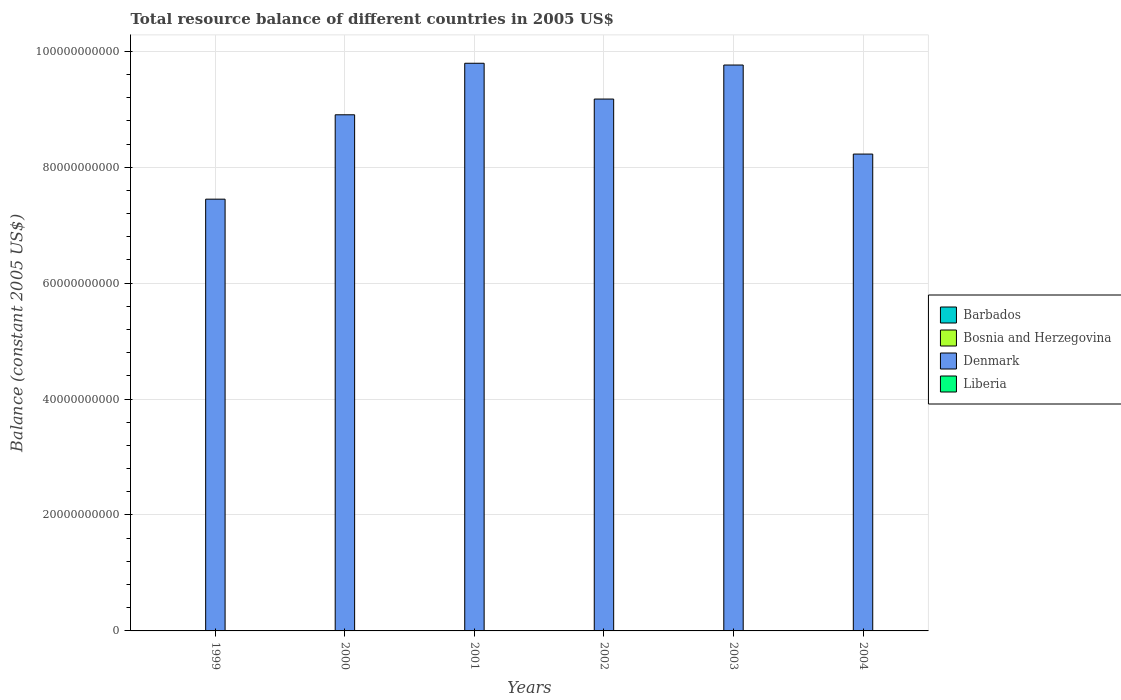How many different coloured bars are there?
Offer a terse response. 2. Are the number of bars per tick equal to the number of legend labels?
Give a very brief answer. No. How many bars are there on the 3rd tick from the right?
Give a very brief answer. 2. What is the total resource balance in Bosnia and Herzegovina in 2003?
Your answer should be very brief. 0. Across all years, what is the maximum total resource balance in Denmark?
Offer a very short reply. 9.79e+1. Across all years, what is the minimum total resource balance in Barbados?
Your answer should be very brief. 0. In which year was the total resource balance in Liberia maximum?
Give a very brief answer. 2002. What is the total total resource balance in Liberia in the graph?
Give a very brief answer. 7.70e+07. What is the difference between the total resource balance in Denmark in 2002 and that in 2004?
Provide a short and direct response. 9.49e+09. What is the difference between the total resource balance in Denmark in 2000 and the total resource balance in Barbados in 2003?
Keep it short and to the point. 8.90e+1. What is the average total resource balance in Denmark per year?
Your answer should be very brief. 8.89e+1. In how many years, is the total resource balance in Bosnia and Herzegovina greater than 76000000000 US$?
Offer a terse response. 0. What is the ratio of the total resource balance in Denmark in 2003 to that in 2004?
Keep it short and to the point. 1.19. Is the total resource balance in Denmark in 1999 less than that in 2003?
Your answer should be compact. Yes. What is the difference between the highest and the second highest total resource balance in Liberia?
Give a very brief answer. 4.96e+07. What is the difference between the highest and the lowest total resource balance in Liberia?
Provide a short and direct response. 6.29e+07. Is it the case that in every year, the sum of the total resource balance in Barbados and total resource balance in Liberia is greater than the total resource balance in Bosnia and Herzegovina?
Keep it short and to the point. No. Are all the bars in the graph horizontal?
Keep it short and to the point. No. What is the difference between two consecutive major ticks on the Y-axis?
Offer a very short reply. 2.00e+1. Are the values on the major ticks of Y-axis written in scientific E-notation?
Offer a terse response. No. Does the graph contain any zero values?
Ensure brevity in your answer.  Yes. Does the graph contain grids?
Your answer should be very brief. Yes. Where does the legend appear in the graph?
Give a very brief answer. Center right. How many legend labels are there?
Make the answer very short. 4. How are the legend labels stacked?
Offer a terse response. Vertical. What is the title of the graph?
Offer a terse response. Total resource balance of different countries in 2005 US$. What is the label or title of the X-axis?
Offer a very short reply. Years. What is the label or title of the Y-axis?
Provide a short and direct response. Balance (constant 2005 US$). What is the Balance (constant 2005 US$) in Denmark in 1999?
Your answer should be very brief. 7.45e+1. What is the Balance (constant 2005 US$) in Barbados in 2000?
Ensure brevity in your answer.  0. What is the Balance (constant 2005 US$) of Bosnia and Herzegovina in 2000?
Your answer should be compact. 0. What is the Balance (constant 2005 US$) of Denmark in 2000?
Offer a terse response. 8.90e+1. What is the Balance (constant 2005 US$) in Denmark in 2001?
Give a very brief answer. 9.79e+1. What is the Balance (constant 2005 US$) of Liberia in 2001?
Your answer should be very brief. 1.33e+07. What is the Balance (constant 2005 US$) of Bosnia and Herzegovina in 2002?
Your answer should be compact. 0. What is the Balance (constant 2005 US$) of Denmark in 2002?
Provide a succinct answer. 9.18e+1. What is the Balance (constant 2005 US$) in Liberia in 2002?
Your answer should be compact. 6.29e+07. What is the Balance (constant 2005 US$) of Bosnia and Herzegovina in 2003?
Give a very brief answer. 0. What is the Balance (constant 2005 US$) of Denmark in 2003?
Make the answer very short. 9.76e+1. What is the Balance (constant 2005 US$) in Liberia in 2003?
Your answer should be compact. 8.06e+05. What is the Balance (constant 2005 US$) of Barbados in 2004?
Provide a short and direct response. 0. What is the Balance (constant 2005 US$) in Denmark in 2004?
Make the answer very short. 8.23e+1. What is the Balance (constant 2005 US$) in Liberia in 2004?
Give a very brief answer. 0. Across all years, what is the maximum Balance (constant 2005 US$) of Denmark?
Provide a short and direct response. 9.79e+1. Across all years, what is the maximum Balance (constant 2005 US$) in Liberia?
Offer a terse response. 6.29e+07. Across all years, what is the minimum Balance (constant 2005 US$) in Denmark?
Provide a succinct answer. 7.45e+1. Across all years, what is the minimum Balance (constant 2005 US$) of Liberia?
Keep it short and to the point. 0. What is the total Balance (constant 2005 US$) in Denmark in the graph?
Offer a terse response. 5.33e+11. What is the total Balance (constant 2005 US$) in Liberia in the graph?
Offer a very short reply. 7.70e+07. What is the difference between the Balance (constant 2005 US$) of Denmark in 1999 and that in 2000?
Offer a very short reply. -1.46e+1. What is the difference between the Balance (constant 2005 US$) in Denmark in 1999 and that in 2001?
Offer a terse response. -2.34e+1. What is the difference between the Balance (constant 2005 US$) in Denmark in 1999 and that in 2002?
Keep it short and to the point. -1.73e+1. What is the difference between the Balance (constant 2005 US$) in Denmark in 1999 and that in 2003?
Provide a short and direct response. -2.31e+1. What is the difference between the Balance (constant 2005 US$) of Denmark in 1999 and that in 2004?
Keep it short and to the point. -7.78e+09. What is the difference between the Balance (constant 2005 US$) of Denmark in 2000 and that in 2001?
Ensure brevity in your answer.  -8.89e+09. What is the difference between the Balance (constant 2005 US$) in Denmark in 2000 and that in 2002?
Provide a short and direct response. -2.71e+09. What is the difference between the Balance (constant 2005 US$) of Denmark in 2000 and that in 2003?
Offer a very short reply. -8.58e+09. What is the difference between the Balance (constant 2005 US$) in Denmark in 2000 and that in 2004?
Provide a short and direct response. 6.78e+09. What is the difference between the Balance (constant 2005 US$) of Denmark in 2001 and that in 2002?
Keep it short and to the point. 6.18e+09. What is the difference between the Balance (constant 2005 US$) of Liberia in 2001 and that in 2002?
Make the answer very short. -4.96e+07. What is the difference between the Balance (constant 2005 US$) in Denmark in 2001 and that in 2003?
Provide a short and direct response. 3.04e+08. What is the difference between the Balance (constant 2005 US$) of Liberia in 2001 and that in 2003?
Offer a terse response. 1.25e+07. What is the difference between the Balance (constant 2005 US$) in Denmark in 2001 and that in 2004?
Your answer should be very brief. 1.57e+1. What is the difference between the Balance (constant 2005 US$) in Denmark in 2002 and that in 2003?
Offer a terse response. -5.87e+09. What is the difference between the Balance (constant 2005 US$) of Liberia in 2002 and that in 2003?
Offer a very short reply. 6.21e+07. What is the difference between the Balance (constant 2005 US$) of Denmark in 2002 and that in 2004?
Provide a short and direct response. 9.49e+09. What is the difference between the Balance (constant 2005 US$) in Denmark in 2003 and that in 2004?
Your answer should be compact. 1.54e+1. What is the difference between the Balance (constant 2005 US$) of Denmark in 1999 and the Balance (constant 2005 US$) of Liberia in 2001?
Provide a short and direct response. 7.45e+1. What is the difference between the Balance (constant 2005 US$) of Denmark in 1999 and the Balance (constant 2005 US$) of Liberia in 2002?
Ensure brevity in your answer.  7.44e+1. What is the difference between the Balance (constant 2005 US$) in Denmark in 1999 and the Balance (constant 2005 US$) in Liberia in 2003?
Give a very brief answer. 7.45e+1. What is the difference between the Balance (constant 2005 US$) of Denmark in 2000 and the Balance (constant 2005 US$) of Liberia in 2001?
Your response must be concise. 8.90e+1. What is the difference between the Balance (constant 2005 US$) in Denmark in 2000 and the Balance (constant 2005 US$) in Liberia in 2002?
Make the answer very short. 8.90e+1. What is the difference between the Balance (constant 2005 US$) in Denmark in 2000 and the Balance (constant 2005 US$) in Liberia in 2003?
Offer a terse response. 8.90e+1. What is the difference between the Balance (constant 2005 US$) of Denmark in 2001 and the Balance (constant 2005 US$) of Liberia in 2002?
Offer a very short reply. 9.79e+1. What is the difference between the Balance (constant 2005 US$) of Denmark in 2001 and the Balance (constant 2005 US$) of Liberia in 2003?
Your answer should be compact. 9.79e+1. What is the difference between the Balance (constant 2005 US$) in Denmark in 2002 and the Balance (constant 2005 US$) in Liberia in 2003?
Give a very brief answer. 9.18e+1. What is the average Balance (constant 2005 US$) in Barbados per year?
Make the answer very short. 0. What is the average Balance (constant 2005 US$) of Denmark per year?
Provide a short and direct response. 8.89e+1. What is the average Balance (constant 2005 US$) in Liberia per year?
Your answer should be very brief. 1.28e+07. In the year 2001, what is the difference between the Balance (constant 2005 US$) in Denmark and Balance (constant 2005 US$) in Liberia?
Your answer should be compact. 9.79e+1. In the year 2002, what is the difference between the Balance (constant 2005 US$) in Denmark and Balance (constant 2005 US$) in Liberia?
Offer a terse response. 9.17e+1. In the year 2003, what is the difference between the Balance (constant 2005 US$) in Denmark and Balance (constant 2005 US$) in Liberia?
Your answer should be compact. 9.76e+1. What is the ratio of the Balance (constant 2005 US$) in Denmark in 1999 to that in 2000?
Your answer should be compact. 0.84. What is the ratio of the Balance (constant 2005 US$) of Denmark in 1999 to that in 2001?
Your answer should be very brief. 0.76. What is the ratio of the Balance (constant 2005 US$) of Denmark in 1999 to that in 2002?
Make the answer very short. 0.81. What is the ratio of the Balance (constant 2005 US$) of Denmark in 1999 to that in 2003?
Give a very brief answer. 0.76. What is the ratio of the Balance (constant 2005 US$) in Denmark in 1999 to that in 2004?
Ensure brevity in your answer.  0.91. What is the ratio of the Balance (constant 2005 US$) in Denmark in 2000 to that in 2001?
Your response must be concise. 0.91. What is the ratio of the Balance (constant 2005 US$) in Denmark in 2000 to that in 2002?
Your response must be concise. 0.97. What is the ratio of the Balance (constant 2005 US$) of Denmark in 2000 to that in 2003?
Provide a succinct answer. 0.91. What is the ratio of the Balance (constant 2005 US$) in Denmark in 2000 to that in 2004?
Offer a terse response. 1.08. What is the ratio of the Balance (constant 2005 US$) in Denmark in 2001 to that in 2002?
Your answer should be very brief. 1.07. What is the ratio of the Balance (constant 2005 US$) of Liberia in 2001 to that in 2002?
Make the answer very short. 0.21. What is the ratio of the Balance (constant 2005 US$) in Liberia in 2001 to that in 2003?
Your response must be concise. 16.51. What is the ratio of the Balance (constant 2005 US$) in Denmark in 2001 to that in 2004?
Your response must be concise. 1.19. What is the ratio of the Balance (constant 2005 US$) of Denmark in 2002 to that in 2003?
Offer a very short reply. 0.94. What is the ratio of the Balance (constant 2005 US$) in Liberia in 2002 to that in 2003?
Your answer should be compact. 77.97. What is the ratio of the Balance (constant 2005 US$) in Denmark in 2002 to that in 2004?
Offer a very short reply. 1.12. What is the ratio of the Balance (constant 2005 US$) in Denmark in 2003 to that in 2004?
Offer a terse response. 1.19. What is the difference between the highest and the second highest Balance (constant 2005 US$) of Denmark?
Make the answer very short. 3.04e+08. What is the difference between the highest and the second highest Balance (constant 2005 US$) in Liberia?
Give a very brief answer. 4.96e+07. What is the difference between the highest and the lowest Balance (constant 2005 US$) in Denmark?
Your response must be concise. 2.34e+1. What is the difference between the highest and the lowest Balance (constant 2005 US$) of Liberia?
Offer a terse response. 6.29e+07. 